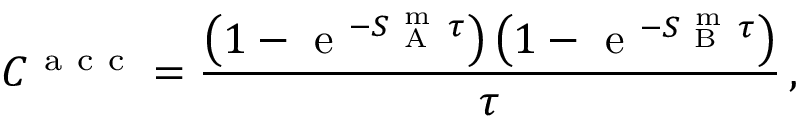Convert formula to latex. <formula><loc_0><loc_0><loc_500><loc_500>C ^ { a c c } = \frac { \left ( 1 - e ^ { - S _ { A } ^ { m } \tau } \right ) \left ( 1 - e ^ { - S _ { B } ^ { m } \tau } \right ) } { \tau } \, ,</formula> 